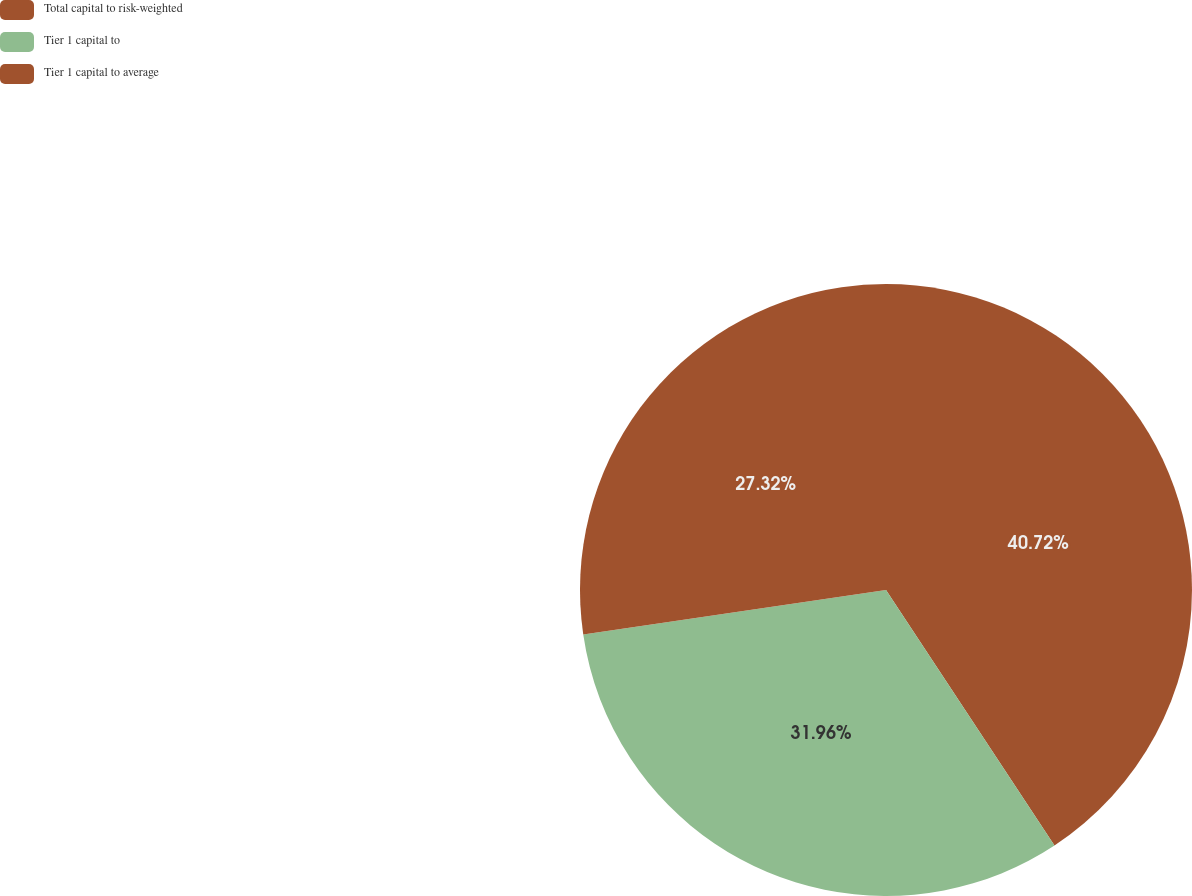Convert chart to OTSL. <chart><loc_0><loc_0><loc_500><loc_500><pie_chart><fcel>Total capital to risk-weighted<fcel>Tier 1 capital to<fcel>Tier 1 capital to average<nl><fcel>40.72%<fcel>31.96%<fcel>27.32%<nl></chart> 